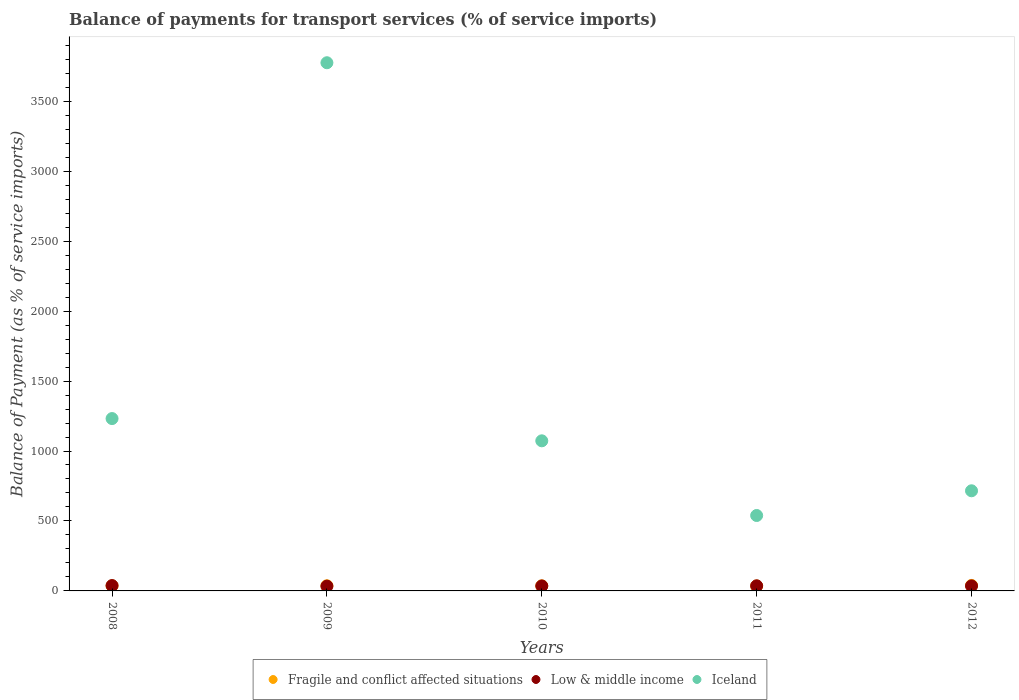How many different coloured dotlines are there?
Give a very brief answer. 3. What is the balance of payments for transport services in Iceland in 2008?
Provide a succinct answer. 1231.8. Across all years, what is the maximum balance of payments for transport services in Iceland?
Provide a short and direct response. 3774.93. Across all years, what is the minimum balance of payments for transport services in Fragile and conflict affected situations?
Your response must be concise. 35.44. In which year was the balance of payments for transport services in Fragile and conflict affected situations maximum?
Offer a very short reply. 2012. In which year was the balance of payments for transport services in Iceland minimum?
Your answer should be compact. 2011. What is the total balance of payments for transport services in Low & middle income in the graph?
Offer a very short reply. 179.85. What is the difference between the balance of payments for transport services in Low & middle income in 2008 and that in 2010?
Your response must be concise. 2.8. What is the difference between the balance of payments for transport services in Fragile and conflict affected situations in 2008 and the balance of payments for transport services in Iceland in 2009?
Your answer should be compact. -3738.29. What is the average balance of payments for transport services in Fragile and conflict affected situations per year?
Your response must be concise. 36.86. In the year 2010, what is the difference between the balance of payments for transport services in Fragile and conflict affected situations and balance of payments for transport services in Iceland?
Ensure brevity in your answer.  -1036.39. In how many years, is the balance of payments for transport services in Low & middle income greater than 3400 %?
Give a very brief answer. 0. What is the ratio of the balance of payments for transport services in Fragile and conflict affected situations in 2008 to that in 2011?
Ensure brevity in your answer.  1.03. What is the difference between the highest and the second highest balance of payments for transport services in Iceland?
Keep it short and to the point. 2543.13. What is the difference between the highest and the lowest balance of payments for transport services in Fragile and conflict affected situations?
Keep it short and to the point. 3.71. Is it the case that in every year, the sum of the balance of payments for transport services in Iceland and balance of payments for transport services in Low & middle income  is greater than the balance of payments for transport services in Fragile and conflict affected situations?
Provide a succinct answer. Yes. How many dotlines are there?
Offer a terse response. 3. How many years are there in the graph?
Make the answer very short. 5. Are the values on the major ticks of Y-axis written in scientific E-notation?
Offer a very short reply. No. How many legend labels are there?
Provide a succinct answer. 3. What is the title of the graph?
Make the answer very short. Balance of payments for transport services (% of service imports). Does "Samoa" appear as one of the legend labels in the graph?
Offer a terse response. No. What is the label or title of the X-axis?
Your answer should be compact. Years. What is the label or title of the Y-axis?
Give a very brief answer. Balance of Payment (as % of service imports). What is the Balance of Payment (as % of service imports) of Fragile and conflict affected situations in 2008?
Ensure brevity in your answer.  36.64. What is the Balance of Payment (as % of service imports) in Low & middle income in 2008?
Give a very brief answer. 38.2. What is the Balance of Payment (as % of service imports) of Iceland in 2008?
Your answer should be compact. 1231.8. What is the Balance of Payment (as % of service imports) of Fragile and conflict affected situations in 2009?
Offer a terse response. 36.7. What is the Balance of Payment (as % of service imports) in Low & middle income in 2009?
Give a very brief answer. 34.1. What is the Balance of Payment (as % of service imports) in Iceland in 2009?
Make the answer very short. 3774.93. What is the Balance of Payment (as % of service imports) in Fragile and conflict affected situations in 2010?
Make the answer very short. 36.39. What is the Balance of Payment (as % of service imports) of Low & middle income in 2010?
Your answer should be compact. 35.41. What is the Balance of Payment (as % of service imports) of Iceland in 2010?
Keep it short and to the point. 1072.78. What is the Balance of Payment (as % of service imports) in Fragile and conflict affected situations in 2011?
Your response must be concise. 35.44. What is the Balance of Payment (as % of service imports) of Low & middle income in 2011?
Offer a very short reply. 36.44. What is the Balance of Payment (as % of service imports) in Iceland in 2011?
Provide a short and direct response. 539.07. What is the Balance of Payment (as % of service imports) of Fragile and conflict affected situations in 2012?
Keep it short and to the point. 39.15. What is the Balance of Payment (as % of service imports) in Low & middle income in 2012?
Your answer should be very brief. 35.7. What is the Balance of Payment (as % of service imports) in Iceland in 2012?
Your response must be concise. 715.64. Across all years, what is the maximum Balance of Payment (as % of service imports) in Fragile and conflict affected situations?
Provide a succinct answer. 39.15. Across all years, what is the maximum Balance of Payment (as % of service imports) in Low & middle income?
Your answer should be compact. 38.2. Across all years, what is the maximum Balance of Payment (as % of service imports) in Iceland?
Offer a terse response. 3774.93. Across all years, what is the minimum Balance of Payment (as % of service imports) in Fragile and conflict affected situations?
Ensure brevity in your answer.  35.44. Across all years, what is the minimum Balance of Payment (as % of service imports) of Low & middle income?
Your response must be concise. 34.1. Across all years, what is the minimum Balance of Payment (as % of service imports) in Iceland?
Ensure brevity in your answer.  539.07. What is the total Balance of Payment (as % of service imports) in Fragile and conflict affected situations in the graph?
Your answer should be very brief. 184.31. What is the total Balance of Payment (as % of service imports) of Low & middle income in the graph?
Your answer should be compact. 179.85. What is the total Balance of Payment (as % of service imports) of Iceland in the graph?
Provide a succinct answer. 7334.22. What is the difference between the Balance of Payment (as % of service imports) of Fragile and conflict affected situations in 2008 and that in 2009?
Keep it short and to the point. -0.07. What is the difference between the Balance of Payment (as % of service imports) in Low & middle income in 2008 and that in 2009?
Give a very brief answer. 4.1. What is the difference between the Balance of Payment (as % of service imports) of Iceland in 2008 and that in 2009?
Provide a short and direct response. -2543.13. What is the difference between the Balance of Payment (as % of service imports) in Fragile and conflict affected situations in 2008 and that in 2010?
Give a very brief answer. 0.24. What is the difference between the Balance of Payment (as % of service imports) of Low & middle income in 2008 and that in 2010?
Keep it short and to the point. 2.8. What is the difference between the Balance of Payment (as % of service imports) in Iceland in 2008 and that in 2010?
Your answer should be compact. 159.01. What is the difference between the Balance of Payment (as % of service imports) of Fragile and conflict affected situations in 2008 and that in 2011?
Provide a short and direct response. 1.2. What is the difference between the Balance of Payment (as % of service imports) of Low & middle income in 2008 and that in 2011?
Provide a succinct answer. 1.76. What is the difference between the Balance of Payment (as % of service imports) in Iceland in 2008 and that in 2011?
Provide a succinct answer. 692.73. What is the difference between the Balance of Payment (as % of service imports) in Fragile and conflict affected situations in 2008 and that in 2012?
Ensure brevity in your answer.  -2.51. What is the difference between the Balance of Payment (as % of service imports) of Low & middle income in 2008 and that in 2012?
Make the answer very short. 2.51. What is the difference between the Balance of Payment (as % of service imports) of Iceland in 2008 and that in 2012?
Your answer should be compact. 516.16. What is the difference between the Balance of Payment (as % of service imports) in Fragile and conflict affected situations in 2009 and that in 2010?
Make the answer very short. 0.31. What is the difference between the Balance of Payment (as % of service imports) in Low & middle income in 2009 and that in 2010?
Keep it short and to the point. -1.3. What is the difference between the Balance of Payment (as % of service imports) in Iceland in 2009 and that in 2010?
Offer a very short reply. 2702.14. What is the difference between the Balance of Payment (as % of service imports) of Fragile and conflict affected situations in 2009 and that in 2011?
Provide a succinct answer. 1.26. What is the difference between the Balance of Payment (as % of service imports) of Low & middle income in 2009 and that in 2011?
Your answer should be very brief. -2.34. What is the difference between the Balance of Payment (as % of service imports) in Iceland in 2009 and that in 2011?
Offer a terse response. 3235.86. What is the difference between the Balance of Payment (as % of service imports) in Fragile and conflict affected situations in 2009 and that in 2012?
Offer a very short reply. -2.45. What is the difference between the Balance of Payment (as % of service imports) in Low & middle income in 2009 and that in 2012?
Offer a very short reply. -1.59. What is the difference between the Balance of Payment (as % of service imports) in Iceland in 2009 and that in 2012?
Provide a succinct answer. 3059.29. What is the difference between the Balance of Payment (as % of service imports) of Fragile and conflict affected situations in 2010 and that in 2011?
Your answer should be compact. 0.95. What is the difference between the Balance of Payment (as % of service imports) in Low & middle income in 2010 and that in 2011?
Keep it short and to the point. -1.04. What is the difference between the Balance of Payment (as % of service imports) of Iceland in 2010 and that in 2011?
Your response must be concise. 533.71. What is the difference between the Balance of Payment (as % of service imports) of Fragile and conflict affected situations in 2010 and that in 2012?
Keep it short and to the point. -2.75. What is the difference between the Balance of Payment (as % of service imports) in Low & middle income in 2010 and that in 2012?
Give a very brief answer. -0.29. What is the difference between the Balance of Payment (as % of service imports) of Iceland in 2010 and that in 2012?
Your answer should be compact. 357.14. What is the difference between the Balance of Payment (as % of service imports) of Fragile and conflict affected situations in 2011 and that in 2012?
Ensure brevity in your answer.  -3.71. What is the difference between the Balance of Payment (as % of service imports) of Low & middle income in 2011 and that in 2012?
Provide a short and direct response. 0.75. What is the difference between the Balance of Payment (as % of service imports) of Iceland in 2011 and that in 2012?
Your answer should be very brief. -176.57. What is the difference between the Balance of Payment (as % of service imports) of Fragile and conflict affected situations in 2008 and the Balance of Payment (as % of service imports) of Low & middle income in 2009?
Your answer should be compact. 2.53. What is the difference between the Balance of Payment (as % of service imports) in Fragile and conflict affected situations in 2008 and the Balance of Payment (as % of service imports) in Iceland in 2009?
Your answer should be compact. -3738.29. What is the difference between the Balance of Payment (as % of service imports) of Low & middle income in 2008 and the Balance of Payment (as % of service imports) of Iceland in 2009?
Offer a very short reply. -3736.72. What is the difference between the Balance of Payment (as % of service imports) of Fragile and conflict affected situations in 2008 and the Balance of Payment (as % of service imports) of Low & middle income in 2010?
Your answer should be very brief. 1.23. What is the difference between the Balance of Payment (as % of service imports) in Fragile and conflict affected situations in 2008 and the Balance of Payment (as % of service imports) in Iceland in 2010?
Give a very brief answer. -1036.15. What is the difference between the Balance of Payment (as % of service imports) in Low & middle income in 2008 and the Balance of Payment (as % of service imports) in Iceland in 2010?
Offer a very short reply. -1034.58. What is the difference between the Balance of Payment (as % of service imports) of Fragile and conflict affected situations in 2008 and the Balance of Payment (as % of service imports) of Low & middle income in 2011?
Offer a very short reply. 0.19. What is the difference between the Balance of Payment (as % of service imports) of Fragile and conflict affected situations in 2008 and the Balance of Payment (as % of service imports) of Iceland in 2011?
Offer a very short reply. -502.44. What is the difference between the Balance of Payment (as % of service imports) of Low & middle income in 2008 and the Balance of Payment (as % of service imports) of Iceland in 2011?
Make the answer very short. -500.87. What is the difference between the Balance of Payment (as % of service imports) in Fragile and conflict affected situations in 2008 and the Balance of Payment (as % of service imports) in Low & middle income in 2012?
Offer a terse response. 0.94. What is the difference between the Balance of Payment (as % of service imports) in Fragile and conflict affected situations in 2008 and the Balance of Payment (as % of service imports) in Iceland in 2012?
Your answer should be compact. -679.01. What is the difference between the Balance of Payment (as % of service imports) of Low & middle income in 2008 and the Balance of Payment (as % of service imports) of Iceland in 2012?
Ensure brevity in your answer.  -677.44. What is the difference between the Balance of Payment (as % of service imports) in Fragile and conflict affected situations in 2009 and the Balance of Payment (as % of service imports) in Low & middle income in 2010?
Provide a succinct answer. 1.29. What is the difference between the Balance of Payment (as % of service imports) of Fragile and conflict affected situations in 2009 and the Balance of Payment (as % of service imports) of Iceland in 2010?
Your answer should be compact. -1036.08. What is the difference between the Balance of Payment (as % of service imports) in Low & middle income in 2009 and the Balance of Payment (as % of service imports) in Iceland in 2010?
Your answer should be compact. -1038.68. What is the difference between the Balance of Payment (as % of service imports) in Fragile and conflict affected situations in 2009 and the Balance of Payment (as % of service imports) in Low & middle income in 2011?
Make the answer very short. 0.26. What is the difference between the Balance of Payment (as % of service imports) of Fragile and conflict affected situations in 2009 and the Balance of Payment (as % of service imports) of Iceland in 2011?
Your answer should be compact. -502.37. What is the difference between the Balance of Payment (as % of service imports) of Low & middle income in 2009 and the Balance of Payment (as % of service imports) of Iceland in 2011?
Ensure brevity in your answer.  -504.97. What is the difference between the Balance of Payment (as % of service imports) of Fragile and conflict affected situations in 2009 and the Balance of Payment (as % of service imports) of Iceland in 2012?
Provide a short and direct response. -678.94. What is the difference between the Balance of Payment (as % of service imports) in Low & middle income in 2009 and the Balance of Payment (as % of service imports) in Iceland in 2012?
Your answer should be compact. -681.54. What is the difference between the Balance of Payment (as % of service imports) in Fragile and conflict affected situations in 2010 and the Balance of Payment (as % of service imports) in Low & middle income in 2011?
Your response must be concise. -0.05. What is the difference between the Balance of Payment (as % of service imports) in Fragile and conflict affected situations in 2010 and the Balance of Payment (as % of service imports) in Iceland in 2011?
Offer a very short reply. -502.68. What is the difference between the Balance of Payment (as % of service imports) of Low & middle income in 2010 and the Balance of Payment (as % of service imports) of Iceland in 2011?
Your response must be concise. -503.67. What is the difference between the Balance of Payment (as % of service imports) of Fragile and conflict affected situations in 2010 and the Balance of Payment (as % of service imports) of Low & middle income in 2012?
Provide a short and direct response. 0.7. What is the difference between the Balance of Payment (as % of service imports) in Fragile and conflict affected situations in 2010 and the Balance of Payment (as % of service imports) in Iceland in 2012?
Offer a very short reply. -679.25. What is the difference between the Balance of Payment (as % of service imports) of Low & middle income in 2010 and the Balance of Payment (as % of service imports) of Iceland in 2012?
Provide a short and direct response. -680.24. What is the difference between the Balance of Payment (as % of service imports) in Fragile and conflict affected situations in 2011 and the Balance of Payment (as % of service imports) in Low & middle income in 2012?
Ensure brevity in your answer.  -0.26. What is the difference between the Balance of Payment (as % of service imports) of Fragile and conflict affected situations in 2011 and the Balance of Payment (as % of service imports) of Iceland in 2012?
Make the answer very short. -680.2. What is the difference between the Balance of Payment (as % of service imports) in Low & middle income in 2011 and the Balance of Payment (as % of service imports) in Iceland in 2012?
Your response must be concise. -679.2. What is the average Balance of Payment (as % of service imports) of Fragile and conflict affected situations per year?
Ensure brevity in your answer.  36.86. What is the average Balance of Payment (as % of service imports) in Low & middle income per year?
Your answer should be very brief. 35.97. What is the average Balance of Payment (as % of service imports) in Iceland per year?
Your answer should be very brief. 1466.84. In the year 2008, what is the difference between the Balance of Payment (as % of service imports) of Fragile and conflict affected situations and Balance of Payment (as % of service imports) of Low & middle income?
Provide a short and direct response. -1.57. In the year 2008, what is the difference between the Balance of Payment (as % of service imports) of Fragile and conflict affected situations and Balance of Payment (as % of service imports) of Iceland?
Give a very brief answer. -1195.16. In the year 2008, what is the difference between the Balance of Payment (as % of service imports) of Low & middle income and Balance of Payment (as % of service imports) of Iceland?
Your response must be concise. -1193.59. In the year 2009, what is the difference between the Balance of Payment (as % of service imports) of Fragile and conflict affected situations and Balance of Payment (as % of service imports) of Low & middle income?
Offer a very short reply. 2.6. In the year 2009, what is the difference between the Balance of Payment (as % of service imports) of Fragile and conflict affected situations and Balance of Payment (as % of service imports) of Iceland?
Provide a short and direct response. -3738.23. In the year 2009, what is the difference between the Balance of Payment (as % of service imports) of Low & middle income and Balance of Payment (as % of service imports) of Iceland?
Ensure brevity in your answer.  -3740.83. In the year 2010, what is the difference between the Balance of Payment (as % of service imports) of Fragile and conflict affected situations and Balance of Payment (as % of service imports) of Low & middle income?
Your answer should be compact. 0.99. In the year 2010, what is the difference between the Balance of Payment (as % of service imports) in Fragile and conflict affected situations and Balance of Payment (as % of service imports) in Iceland?
Give a very brief answer. -1036.39. In the year 2010, what is the difference between the Balance of Payment (as % of service imports) in Low & middle income and Balance of Payment (as % of service imports) in Iceland?
Ensure brevity in your answer.  -1037.38. In the year 2011, what is the difference between the Balance of Payment (as % of service imports) in Fragile and conflict affected situations and Balance of Payment (as % of service imports) in Low & middle income?
Your answer should be compact. -1.01. In the year 2011, what is the difference between the Balance of Payment (as % of service imports) in Fragile and conflict affected situations and Balance of Payment (as % of service imports) in Iceland?
Keep it short and to the point. -503.63. In the year 2011, what is the difference between the Balance of Payment (as % of service imports) in Low & middle income and Balance of Payment (as % of service imports) in Iceland?
Ensure brevity in your answer.  -502.63. In the year 2012, what is the difference between the Balance of Payment (as % of service imports) in Fragile and conflict affected situations and Balance of Payment (as % of service imports) in Low & middle income?
Ensure brevity in your answer.  3.45. In the year 2012, what is the difference between the Balance of Payment (as % of service imports) in Fragile and conflict affected situations and Balance of Payment (as % of service imports) in Iceland?
Give a very brief answer. -676.49. In the year 2012, what is the difference between the Balance of Payment (as % of service imports) in Low & middle income and Balance of Payment (as % of service imports) in Iceland?
Provide a short and direct response. -679.95. What is the ratio of the Balance of Payment (as % of service imports) of Low & middle income in 2008 to that in 2009?
Keep it short and to the point. 1.12. What is the ratio of the Balance of Payment (as % of service imports) in Iceland in 2008 to that in 2009?
Offer a very short reply. 0.33. What is the ratio of the Balance of Payment (as % of service imports) of Fragile and conflict affected situations in 2008 to that in 2010?
Your answer should be very brief. 1.01. What is the ratio of the Balance of Payment (as % of service imports) of Low & middle income in 2008 to that in 2010?
Your response must be concise. 1.08. What is the ratio of the Balance of Payment (as % of service imports) of Iceland in 2008 to that in 2010?
Keep it short and to the point. 1.15. What is the ratio of the Balance of Payment (as % of service imports) of Fragile and conflict affected situations in 2008 to that in 2011?
Make the answer very short. 1.03. What is the ratio of the Balance of Payment (as % of service imports) of Low & middle income in 2008 to that in 2011?
Ensure brevity in your answer.  1.05. What is the ratio of the Balance of Payment (as % of service imports) in Iceland in 2008 to that in 2011?
Your response must be concise. 2.29. What is the ratio of the Balance of Payment (as % of service imports) in Fragile and conflict affected situations in 2008 to that in 2012?
Keep it short and to the point. 0.94. What is the ratio of the Balance of Payment (as % of service imports) in Low & middle income in 2008 to that in 2012?
Keep it short and to the point. 1.07. What is the ratio of the Balance of Payment (as % of service imports) of Iceland in 2008 to that in 2012?
Your answer should be compact. 1.72. What is the ratio of the Balance of Payment (as % of service imports) of Fragile and conflict affected situations in 2009 to that in 2010?
Offer a terse response. 1.01. What is the ratio of the Balance of Payment (as % of service imports) of Low & middle income in 2009 to that in 2010?
Ensure brevity in your answer.  0.96. What is the ratio of the Balance of Payment (as % of service imports) of Iceland in 2009 to that in 2010?
Your response must be concise. 3.52. What is the ratio of the Balance of Payment (as % of service imports) of Fragile and conflict affected situations in 2009 to that in 2011?
Your answer should be compact. 1.04. What is the ratio of the Balance of Payment (as % of service imports) of Low & middle income in 2009 to that in 2011?
Ensure brevity in your answer.  0.94. What is the ratio of the Balance of Payment (as % of service imports) in Iceland in 2009 to that in 2011?
Provide a succinct answer. 7. What is the ratio of the Balance of Payment (as % of service imports) in Fragile and conflict affected situations in 2009 to that in 2012?
Your answer should be very brief. 0.94. What is the ratio of the Balance of Payment (as % of service imports) in Low & middle income in 2009 to that in 2012?
Ensure brevity in your answer.  0.96. What is the ratio of the Balance of Payment (as % of service imports) in Iceland in 2009 to that in 2012?
Provide a succinct answer. 5.27. What is the ratio of the Balance of Payment (as % of service imports) in Fragile and conflict affected situations in 2010 to that in 2011?
Ensure brevity in your answer.  1.03. What is the ratio of the Balance of Payment (as % of service imports) in Low & middle income in 2010 to that in 2011?
Offer a terse response. 0.97. What is the ratio of the Balance of Payment (as % of service imports) of Iceland in 2010 to that in 2011?
Your response must be concise. 1.99. What is the ratio of the Balance of Payment (as % of service imports) in Fragile and conflict affected situations in 2010 to that in 2012?
Your answer should be compact. 0.93. What is the ratio of the Balance of Payment (as % of service imports) of Low & middle income in 2010 to that in 2012?
Your response must be concise. 0.99. What is the ratio of the Balance of Payment (as % of service imports) in Iceland in 2010 to that in 2012?
Provide a short and direct response. 1.5. What is the ratio of the Balance of Payment (as % of service imports) of Fragile and conflict affected situations in 2011 to that in 2012?
Provide a short and direct response. 0.91. What is the ratio of the Balance of Payment (as % of service imports) in Low & middle income in 2011 to that in 2012?
Provide a short and direct response. 1.02. What is the ratio of the Balance of Payment (as % of service imports) in Iceland in 2011 to that in 2012?
Provide a succinct answer. 0.75. What is the difference between the highest and the second highest Balance of Payment (as % of service imports) in Fragile and conflict affected situations?
Provide a short and direct response. 2.45. What is the difference between the highest and the second highest Balance of Payment (as % of service imports) of Low & middle income?
Ensure brevity in your answer.  1.76. What is the difference between the highest and the second highest Balance of Payment (as % of service imports) in Iceland?
Offer a terse response. 2543.13. What is the difference between the highest and the lowest Balance of Payment (as % of service imports) in Fragile and conflict affected situations?
Your answer should be compact. 3.71. What is the difference between the highest and the lowest Balance of Payment (as % of service imports) in Low & middle income?
Offer a terse response. 4.1. What is the difference between the highest and the lowest Balance of Payment (as % of service imports) in Iceland?
Your response must be concise. 3235.86. 